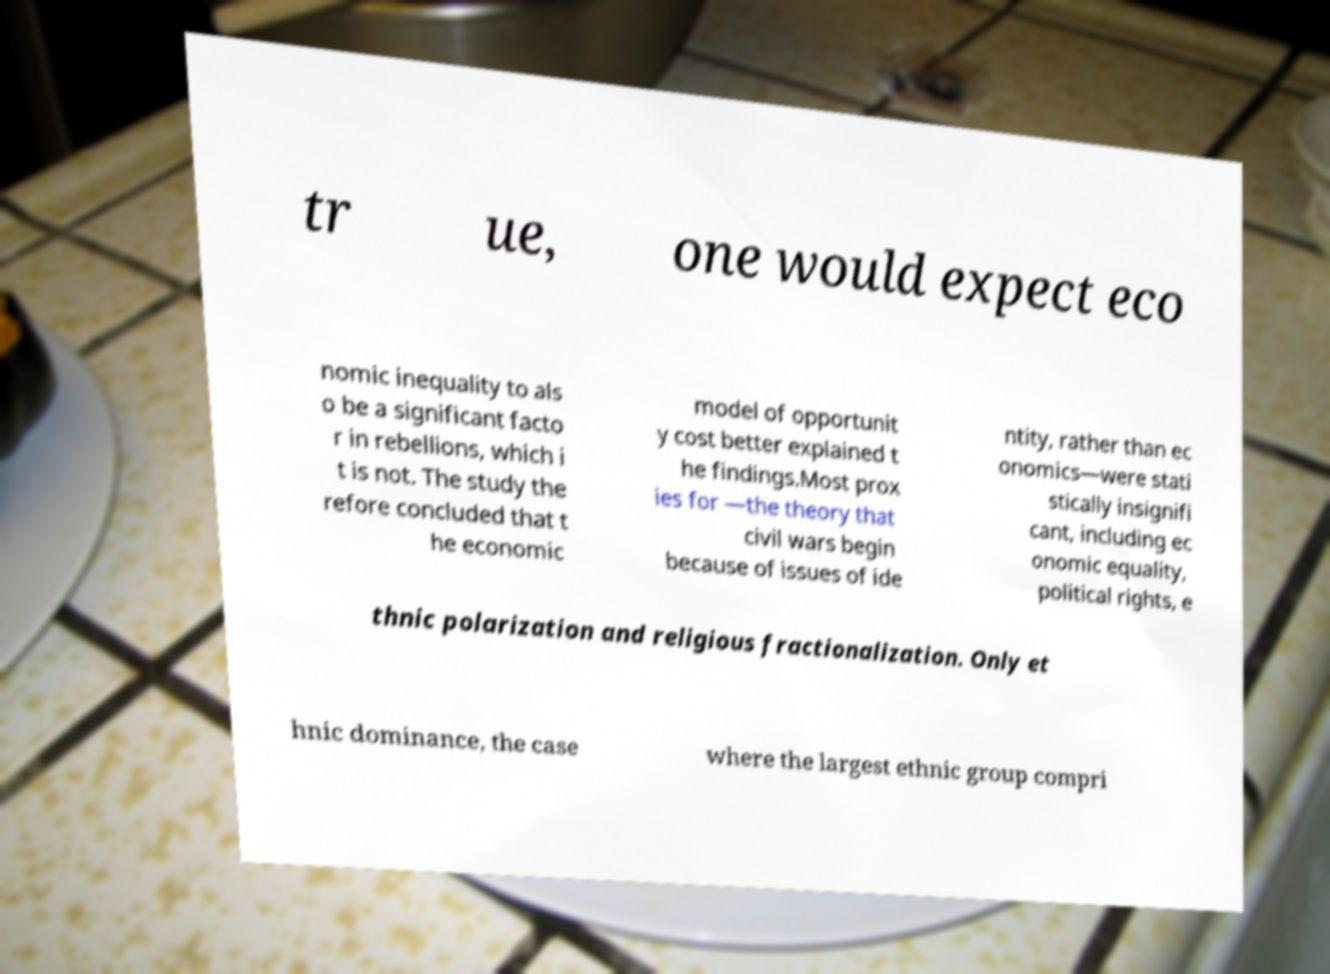Please read and relay the text visible in this image. What does it say? tr ue, one would expect eco nomic inequality to als o be a significant facto r in rebellions, which i t is not. The study the refore concluded that t he economic model of opportunit y cost better explained t he findings.Most prox ies for —the theory that civil wars begin because of issues of ide ntity, rather than ec onomics—were stati stically insignifi cant, including ec onomic equality, political rights, e thnic polarization and religious fractionalization. Only et hnic dominance, the case where the largest ethnic group compri 